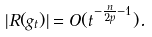Convert formula to latex. <formula><loc_0><loc_0><loc_500><loc_500>| R ( g _ { t } ) | = O ( t ^ { - \frac { n } { 2 p } - 1 } ) .</formula> 